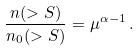Convert formula to latex. <formula><loc_0><loc_0><loc_500><loc_500>\frac { n ( > S ) } { n _ { 0 } ( > S ) } = \mu ^ { \alpha - 1 } \, .</formula> 